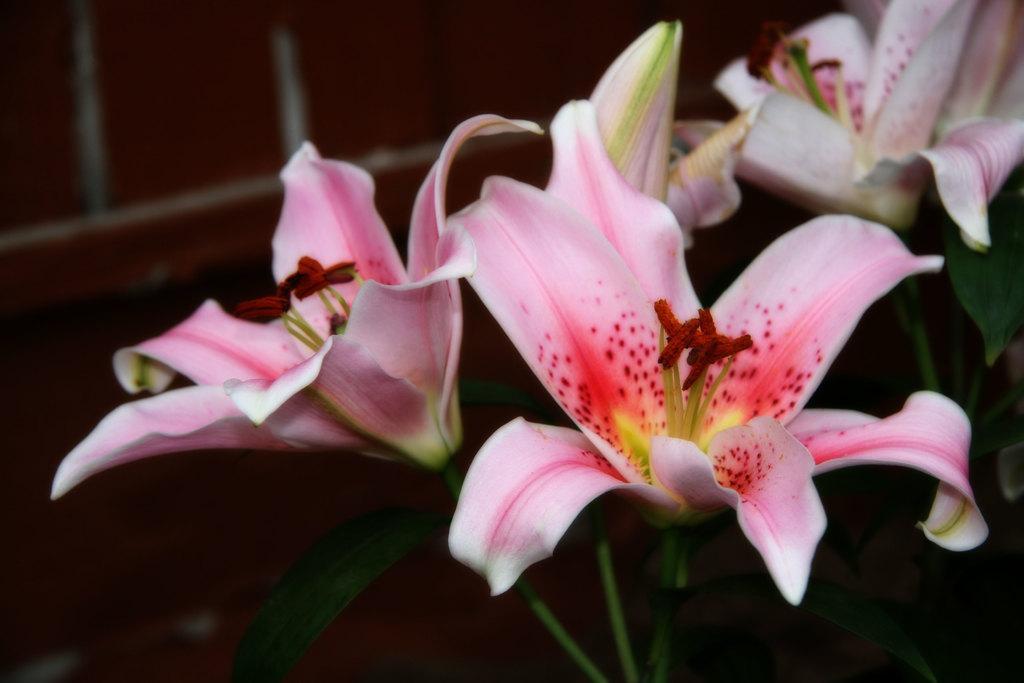How would you summarize this image in a sentence or two? In this picture we can see there are plants with the flowers. Behind the flowers, it looks like a wall. 